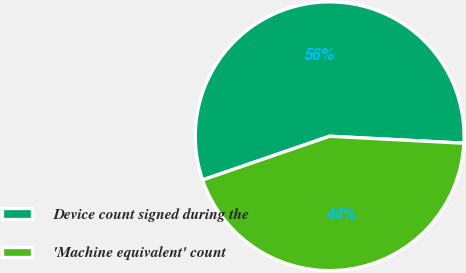Convert chart to OTSL. <chart><loc_0><loc_0><loc_500><loc_500><pie_chart><fcel>Device count signed during the<fcel>'Machine equivalent' count<nl><fcel>56.1%<fcel>43.9%<nl></chart> 